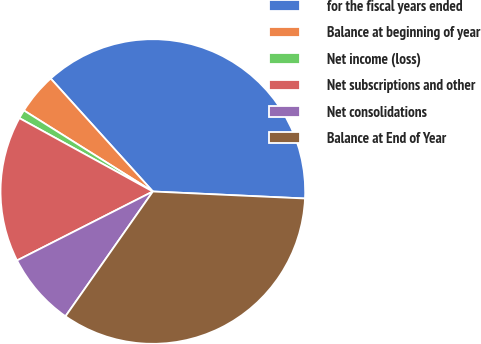Convert chart to OTSL. <chart><loc_0><loc_0><loc_500><loc_500><pie_chart><fcel>for the fiscal years ended<fcel>Balance at beginning of year<fcel>Net income (loss)<fcel>Net subscriptions and other<fcel>Net consolidations<fcel>Balance at End of Year<nl><fcel>37.43%<fcel>4.37%<fcel>0.93%<fcel>15.48%<fcel>7.8%<fcel>33.99%<nl></chart> 